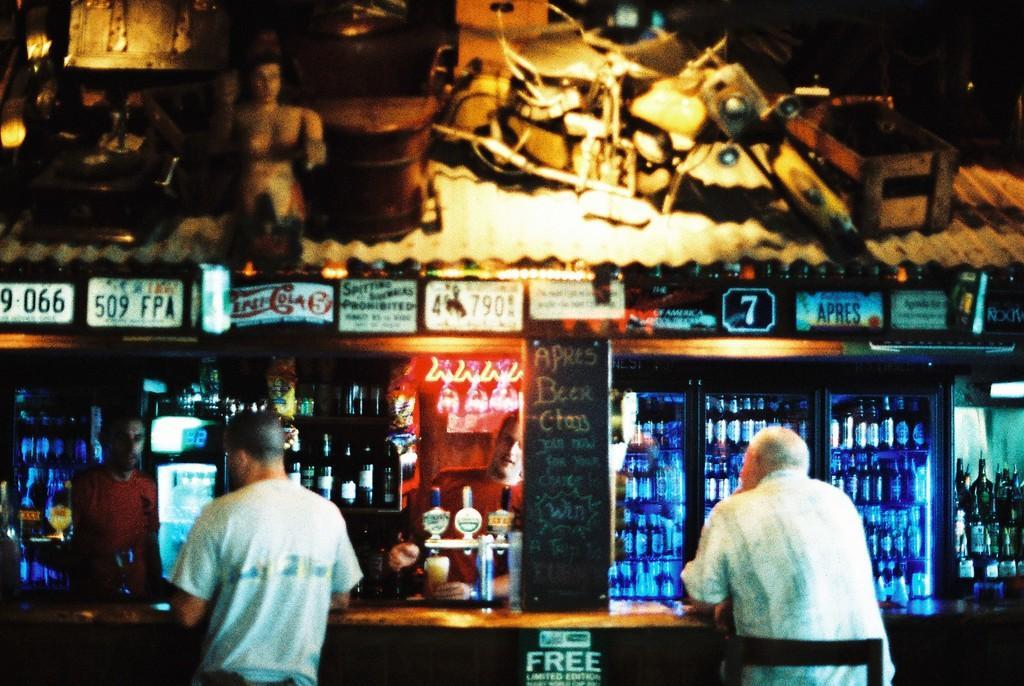How would you summarize this image in a sentence or two? In this picture they are two men wearing white color t-shirt sitting in the bar counter. Behind you can see the bar counter with many bottles placed in the shelf. Above we can see the poster on the wall. 